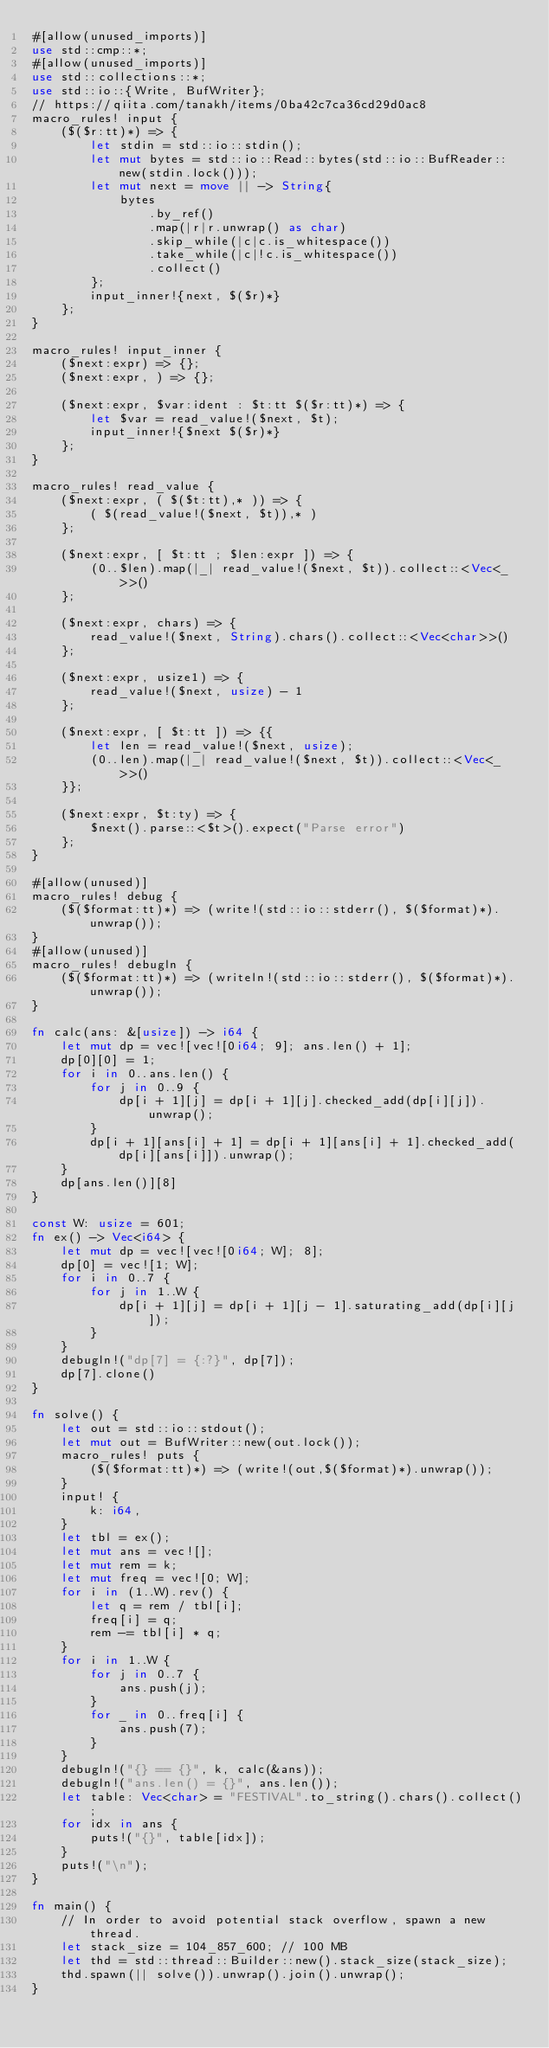<code> <loc_0><loc_0><loc_500><loc_500><_Rust_>#[allow(unused_imports)]
use std::cmp::*;
#[allow(unused_imports)]
use std::collections::*;
use std::io::{Write, BufWriter};
// https://qiita.com/tanakh/items/0ba42c7ca36cd29d0ac8
macro_rules! input {
    ($($r:tt)*) => {
        let stdin = std::io::stdin();
        let mut bytes = std::io::Read::bytes(std::io::BufReader::new(stdin.lock()));
        let mut next = move || -> String{
            bytes
                .by_ref()
                .map(|r|r.unwrap() as char)
                .skip_while(|c|c.is_whitespace())
                .take_while(|c|!c.is_whitespace())
                .collect()
        };
        input_inner!{next, $($r)*}
    };
}

macro_rules! input_inner {
    ($next:expr) => {};
    ($next:expr, ) => {};

    ($next:expr, $var:ident : $t:tt $($r:tt)*) => {
        let $var = read_value!($next, $t);
        input_inner!{$next $($r)*}
    };
}

macro_rules! read_value {
    ($next:expr, ( $($t:tt),* )) => {
        ( $(read_value!($next, $t)),* )
    };

    ($next:expr, [ $t:tt ; $len:expr ]) => {
        (0..$len).map(|_| read_value!($next, $t)).collect::<Vec<_>>()
    };

    ($next:expr, chars) => {
        read_value!($next, String).chars().collect::<Vec<char>>()
    };

    ($next:expr, usize1) => {
        read_value!($next, usize) - 1
    };

    ($next:expr, [ $t:tt ]) => {{
        let len = read_value!($next, usize);
        (0..len).map(|_| read_value!($next, $t)).collect::<Vec<_>>()
    }};

    ($next:expr, $t:ty) => {
        $next().parse::<$t>().expect("Parse error")
    };
}

#[allow(unused)]
macro_rules! debug {
    ($($format:tt)*) => (write!(std::io::stderr(), $($format)*).unwrap());
}
#[allow(unused)]
macro_rules! debugln {
    ($($format:tt)*) => (writeln!(std::io::stderr(), $($format)*).unwrap());
}

fn calc(ans: &[usize]) -> i64 {
    let mut dp = vec![vec![0i64; 9]; ans.len() + 1];
    dp[0][0] = 1;
    for i in 0..ans.len() {
        for j in 0..9 {
            dp[i + 1][j] = dp[i + 1][j].checked_add(dp[i][j]).unwrap();
        }
        dp[i + 1][ans[i] + 1] = dp[i + 1][ans[i] + 1].checked_add(dp[i][ans[i]]).unwrap();
    }
    dp[ans.len()][8]
}

const W: usize = 601;
fn ex() -> Vec<i64> {
    let mut dp = vec![vec![0i64; W]; 8];
    dp[0] = vec![1; W];
    for i in 0..7 {
        for j in 1..W {
            dp[i + 1][j] = dp[i + 1][j - 1].saturating_add(dp[i][j]);
        }
    }
    debugln!("dp[7] = {:?}", dp[7]);
    dp[7].clone()
}

fn solve() {
    let out = std::io::stdout();
    let mut out = BufWriter::new(out.lock());
    macro_rules! puts {
        ($($format:tt)*) => (write!(out,$($format)*).unwrap());
    }
    input! {
        k: i64,
    }
    let tbl = ex();
    let mut ans = vec![];
    let mut rem = k;
    let mut freq = vec![0; W];
    for i in (1..W).rev() {
        let q = rem / tbl[i];
        freq[i] = q;
        rem -= tbl[i] * q;
    }
    for i in 1..W {
        for j in 0..7 {
            ans.push(j);
        }
        for _ in 0..freq[i] {
            ans.push(7);
        }
    }
    debugln!("{} == {}", k, calc(&ans));
    debugln!("ans.len() = {}", ans.len());
    let table: Vec<char> = "FESTIVAL".to_string().chars().collect();
    for idx in ans {
        puts!("{}", table[idx]);
    }
    puts!("\n");
}

fn main() {
    // In order to avoid potential stack overflow, spawn a new thread.
    let stack_size = 104_857_600; // 100 MB
    let thd = std::thread::Builder::new().stack_size(stack_size);
    thd.spawn(|| solve()).unwrap().join().unwrap();
}
</code> 